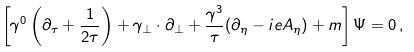<formula> <loc_0><loc_0><loc_500><loc_500>\left [ \gamma ^ { 0 } \left ( \partial _ { \tau } + { \frac { 1 } { 2 \tau } } \right ) + { \gamma } _ { \perp } \cdot \partial _ { \perp } + { \frac { \gamma ^ { 3 } } { \tau } } ( \partial _ { \eta } - i e A _ { \eta } ) + m \right ] \Psi = 0 \, ,</formula> 